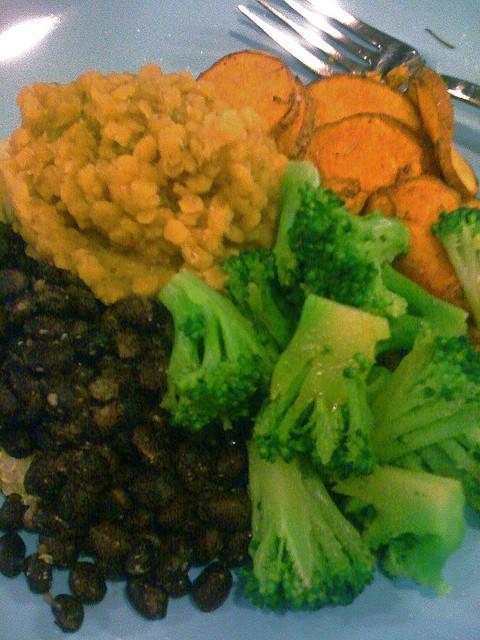How many different ingredients can you see?
Give a very brief answer. 4. How many broccolis are visible?
Give a very brief answer. 2. How many carrots are in the photo?
Give a very brief answer. 3. 